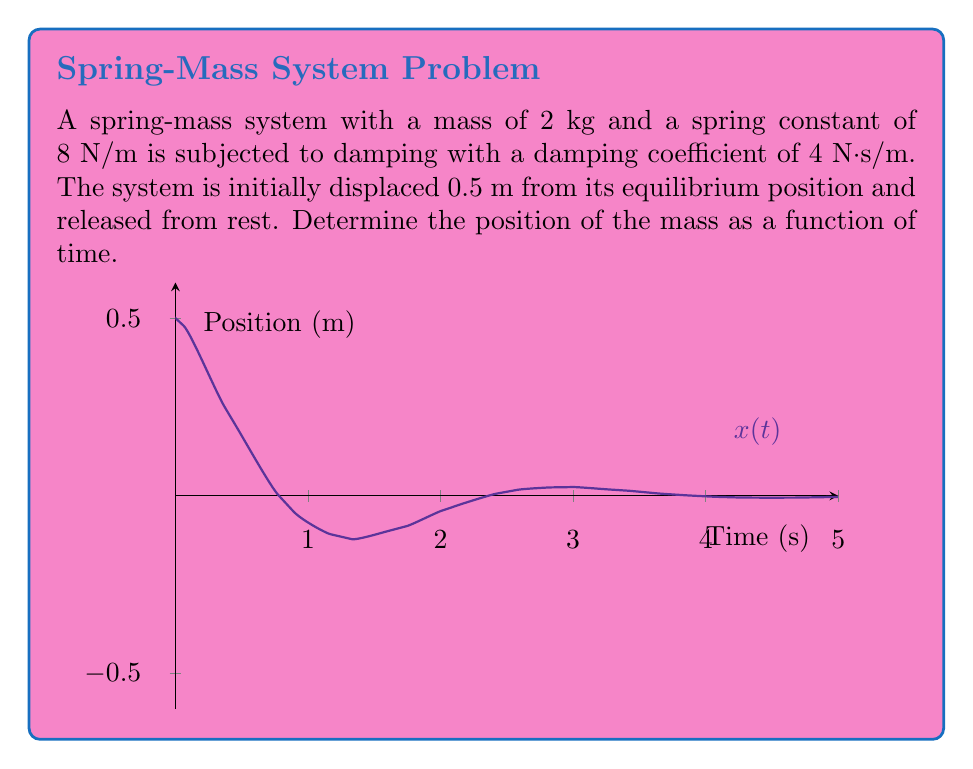Teach me how to tackle this problem. To solve this problem, we'll use the second-order differential equation for a damped spring-mass system:

$$m\frac{d^2x}{dt^2} + c\frac{dx}{dt} + kx = 0$$

Where:
$m$ = mass (2 kg)
$c$ = damping coefficient (4 N·s/m)
$k$ = spring constant (8 N/m)

Step 1: Substitute the given values into the equation:

$$2\frac{d^2x}{dt^2} + 4\frac{dx}{dt} + 8x = 0$$

Step 2: Divide by m (2) to get the standard form:

$$\frac{d^2x}{dt^2} + 2\frac{dx}{dt} + 4x = 0$$

Step 3: The characteristic equation is:

$$r^2 + 2r + 4 = 0$$

Step 4: Solve the characteristic equation:

$$r = \frac{-2 \pm \sqrt{4 - 16}}{2} = -1 \pm i\sqrt{3}$$

Step 5: The general solution is:

$$x(t) = e^{-t}(A\cos(\sqrt{3}t) + B\sin(\sqrt{3}t))$$

Step 6: Apply initial conditions:
At $t=0$, $x(0) = 0.5$ and $x'(0) = 0$

From $x(0) = 0.5$: $A = 0.5$

From $x'(0) = 0$: $-0.5 + \sqrt{3}B = 0$, so $B = \frac{0.5}{\sqrt{3}}$

Step 7: The final solution is:

$$x(t) = e^{-t}(0.5\cos(\sqrt{3}t) + \frac{0.5}{\sqrt{3}}\sin(\sqrt{3}t))$$

This can be simplified to:

$$x(t) = 0.5e^{-t}(\cos(\sqrt{3}t) + \frac{1}{\sqrt{3}}\sin(\sqrt{3}t))$$
Answer: $x(t) = 0.5e^{-t}(\cos(\sqrt{3}t) + \frac{1}{\sqrt{3}}\sin(\sqrt{3}t))$ 